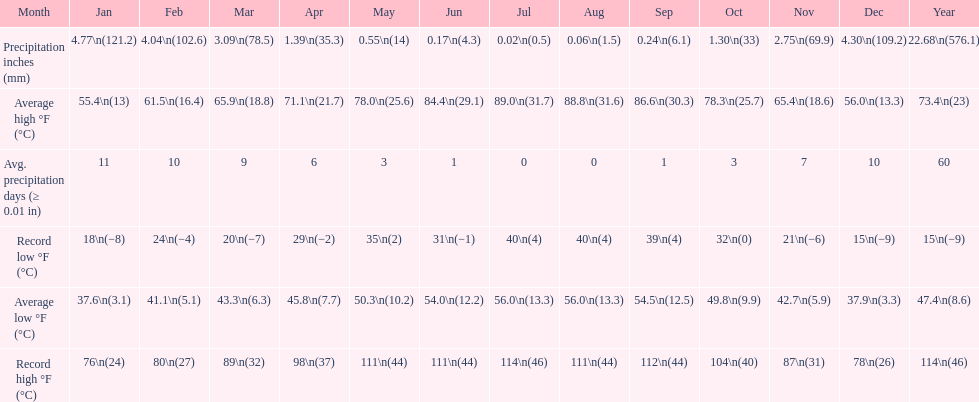In how many months is the record low beneath 25 degrees? 6. Write the full table. {'header': ['Month', 'Jan', 'Feb', 'Mar', 'Apr', 'May', 'Jun', 'Jul', 'Aug', 'Sep', 'Oct', 'Nov', 'Dec', 'Year'], 'rows': [['Precipitation inches (mm)', '4.77\\n(121.2)', '4.04\\n(102.6)', '3.09\\n(78.5)', '1.39\\n(35.3)', '0.55\\n(14)', '0.17\\n(4.3)', '0.02\\n(0.5)', '0.06\\n(1.5)', '0.24\\n(6.1)', '1.30\\n(33)', '2.75\\n(69.9)', '4.30\\n(109.2)', '22.68\\n(576.1)'], ['Average high °F (°C)', '55.4\\n(13)', '61.5\\n(16.4)', '65.9\\n(18.8)', '71.1\\n(21.7)', '78.0\\n(25.6)', '84.4\\n(29.1)', '89.0\\n(31.7)', '88.8\\n(31.6)', '86.6\\n(30.3)', '78.3\\n(25.7)', '65.4\\n(18.6)', '56.0\\n(13.3)', '73.4\\n(23)'], ['Avg. precipitation days (≥ 0.01 in)', '11', '10', '9', '6', '3', '1', '0', '0', '1', '3', '7', '10', '60'], ['Record low °F (°C)', '18\\n(−8)', '24\\n(−4)', '20\\n(−7)', '29\\n(−2)', '35\\n(2)', '31\\n(−1)', '40\\n(4)', '40\\n(4)', '39\\n(4)', '32\\n(0)', '21\\n(−6)', '15\\n(−9)', '15\\n(−9)'], ['Average low °F (°C)', '37.6\\n(3.1)', '41.1\\n(5.1)', '43.3\\n(6.3)', '45.8\\n(7.7)', '50.3\\n(10.2)', '54.0\\n(12.2)', '56.0\\n(13.3)', '56.0\\n(13.3)', '54.5\\n(12.5)', '49.8\\n(9.9)', '42.7\\n(5.9)', '37.9\\n(3.3)', '47.4\\n(8.6)'], ['Record high °F (°C)', '76\\n(24)', '80\\n(27)', '89\\n(32)', '98\\n(37)', '111\\n(44)', '111\\n(44)', '114\\n(46)', '111\\n(44)', '112\\n(44)', '104\\n(40)', '87\\n(31)', '78\\n(26)', '114\\n(46)']]} 